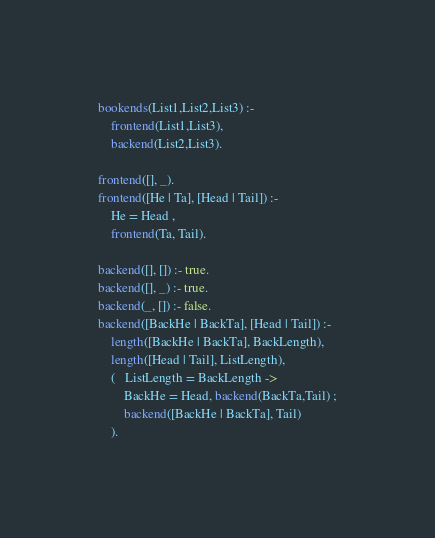<code> <loc_0><loc_0><loc_500><loc_500><_Prolog_>bookends(List1,List2,List3) :-
    frontend(List1,List3),
    backend(List2,List3).

frontend([], _).
frontend([He | Ta], [Head | Tail]) :-
    He = Head ,
    frontend(Ta, Tail).

backend([], []) :- true.
backend([], _) :- true.
backend(_, []) :- false.
backend([BackHe | BackTa], [Head | Tail]) :-
    length([BackHe | BackTa], BackLength),
    length([Head | Tail], ListLength),
    (   ListLength = BackLength ->  
    	BackHe = Head, backend(BackTa,Tail) ;
    	backend([BackHe | BackTa], Tail)
    ).
</code> 